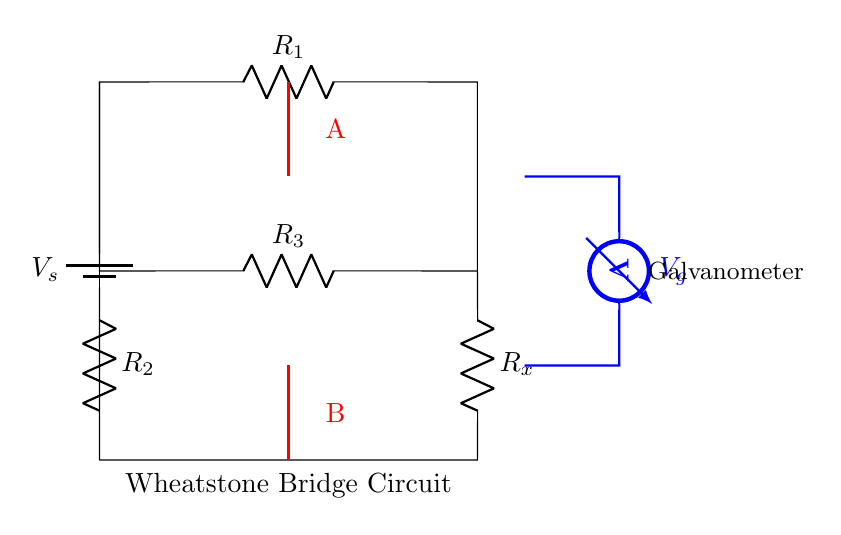What is the voltage source in the circuit? The voltage source is represented as V_s at the top of the circuit diagram.
Answer: V_s What is the value of the resistor labeled R_1? The resistor labeled R_1 does not have a specific value shown in the diagram; it is simply labeled R_1.
Answer: R_1 How many resistors are present in the Wheatstone bridge circuit? The circuit diagram shows a total of four resistors: R_1, R_2, R_3, and R_x.
Answer: Four What does the galvanometer indicate in the circuit? The galvanometer measures the potential difference (voltage) between points A and B in the circuit.
Answer: Voltage What is the significance of the bridge being balanced? When the Wheatstone bridge is balanced, there is no current flowing through the galvanometer, which allows for precise resistance measurements.
Answer: No current If R_x equals 10 ohms and R_1 equals R_3, what condition must R_2 satisfy for the bridge to be balanced? For the bridge to be balanced, the ratio of R_1 to R_2 must equal the ratio of R_x to R_3. Hence, R_2 must equal R_x when R_1 equals R_3.
Answer: R_2 = R_x What happens when the Wheatstone bridge is unbalanced? When the bridge is unbalanced, the galvanometer will show a current indicating a voltage difference between points A and B, which can lead to inaccurate measurements.
Answer: Current flows through galvanometer 